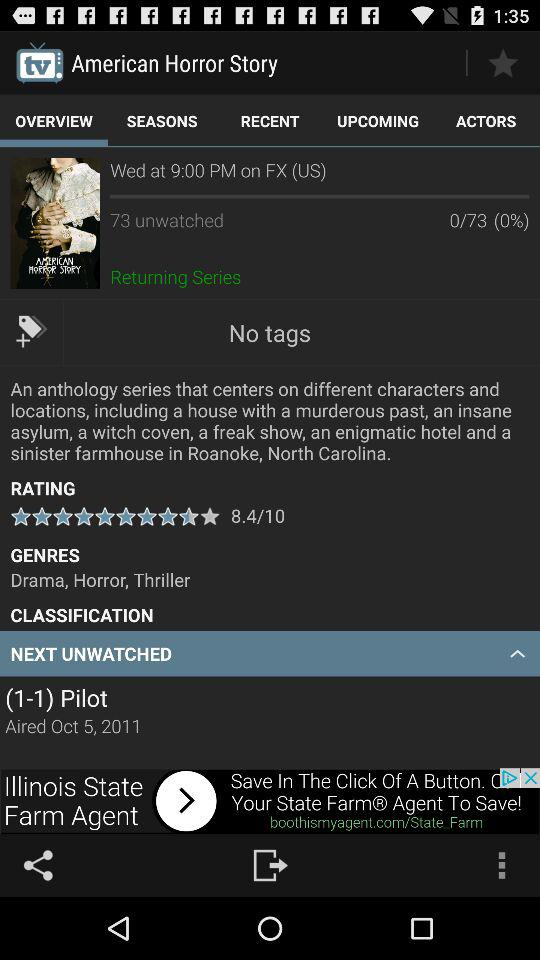What is the rating of the "American Horror Story" TV series? The rating is 8.4. 